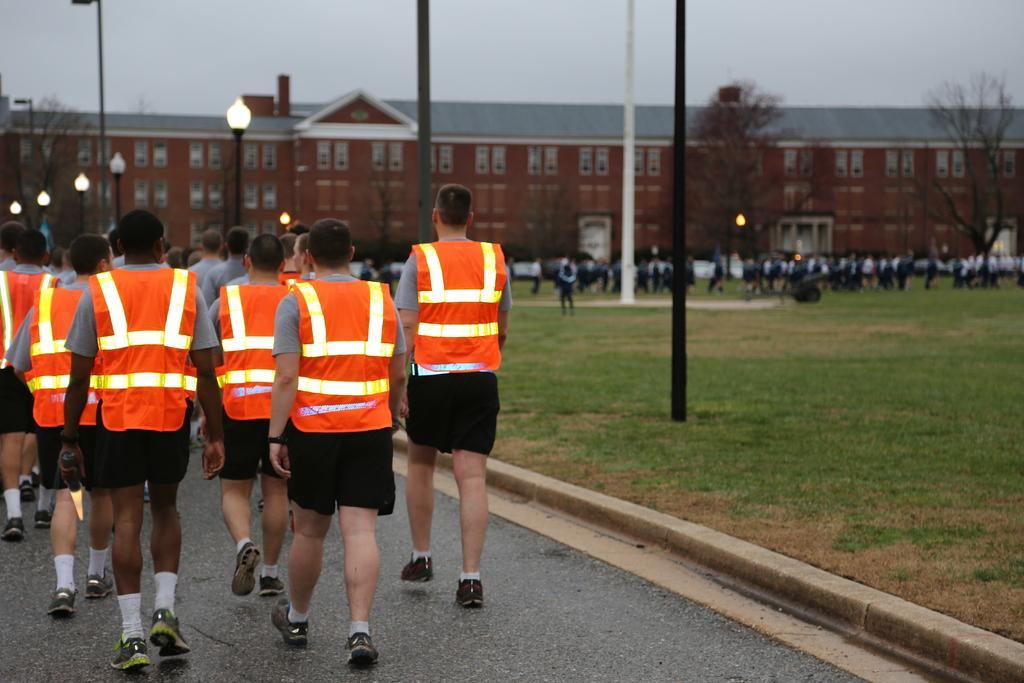Describe this image in one or two sentences. In this image I can see the group of people with aprons and the ash and back color dresses. These people are walking on the road. To the side of the road I can see the light poles, the group of people and many trees. In the background I can see the buildings and the sky. 